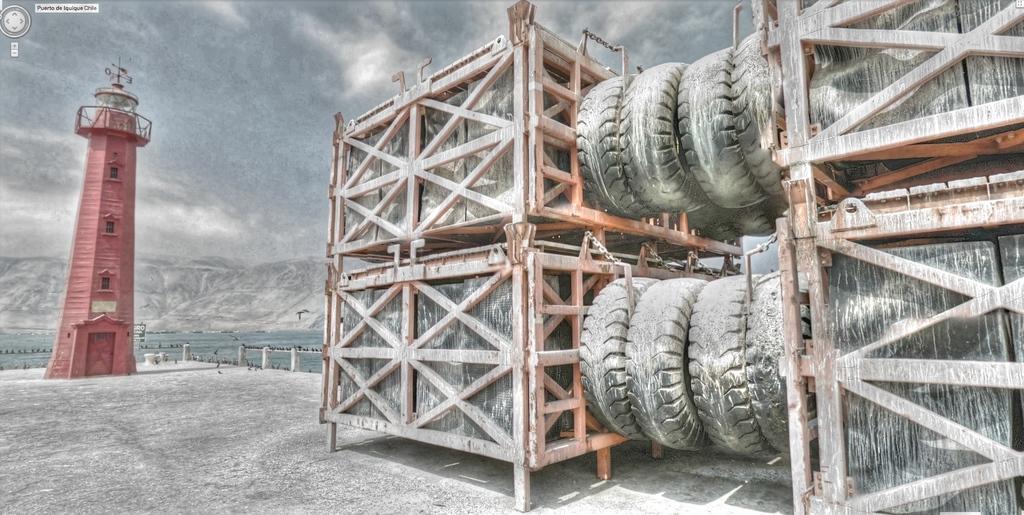Could you give a brief overview of what you see in this image? In the image we can see there are many tires changed. These are the container boxes, footpath, tower, mountain and a cloudy sky. There is water and we can see there are even many birds. 